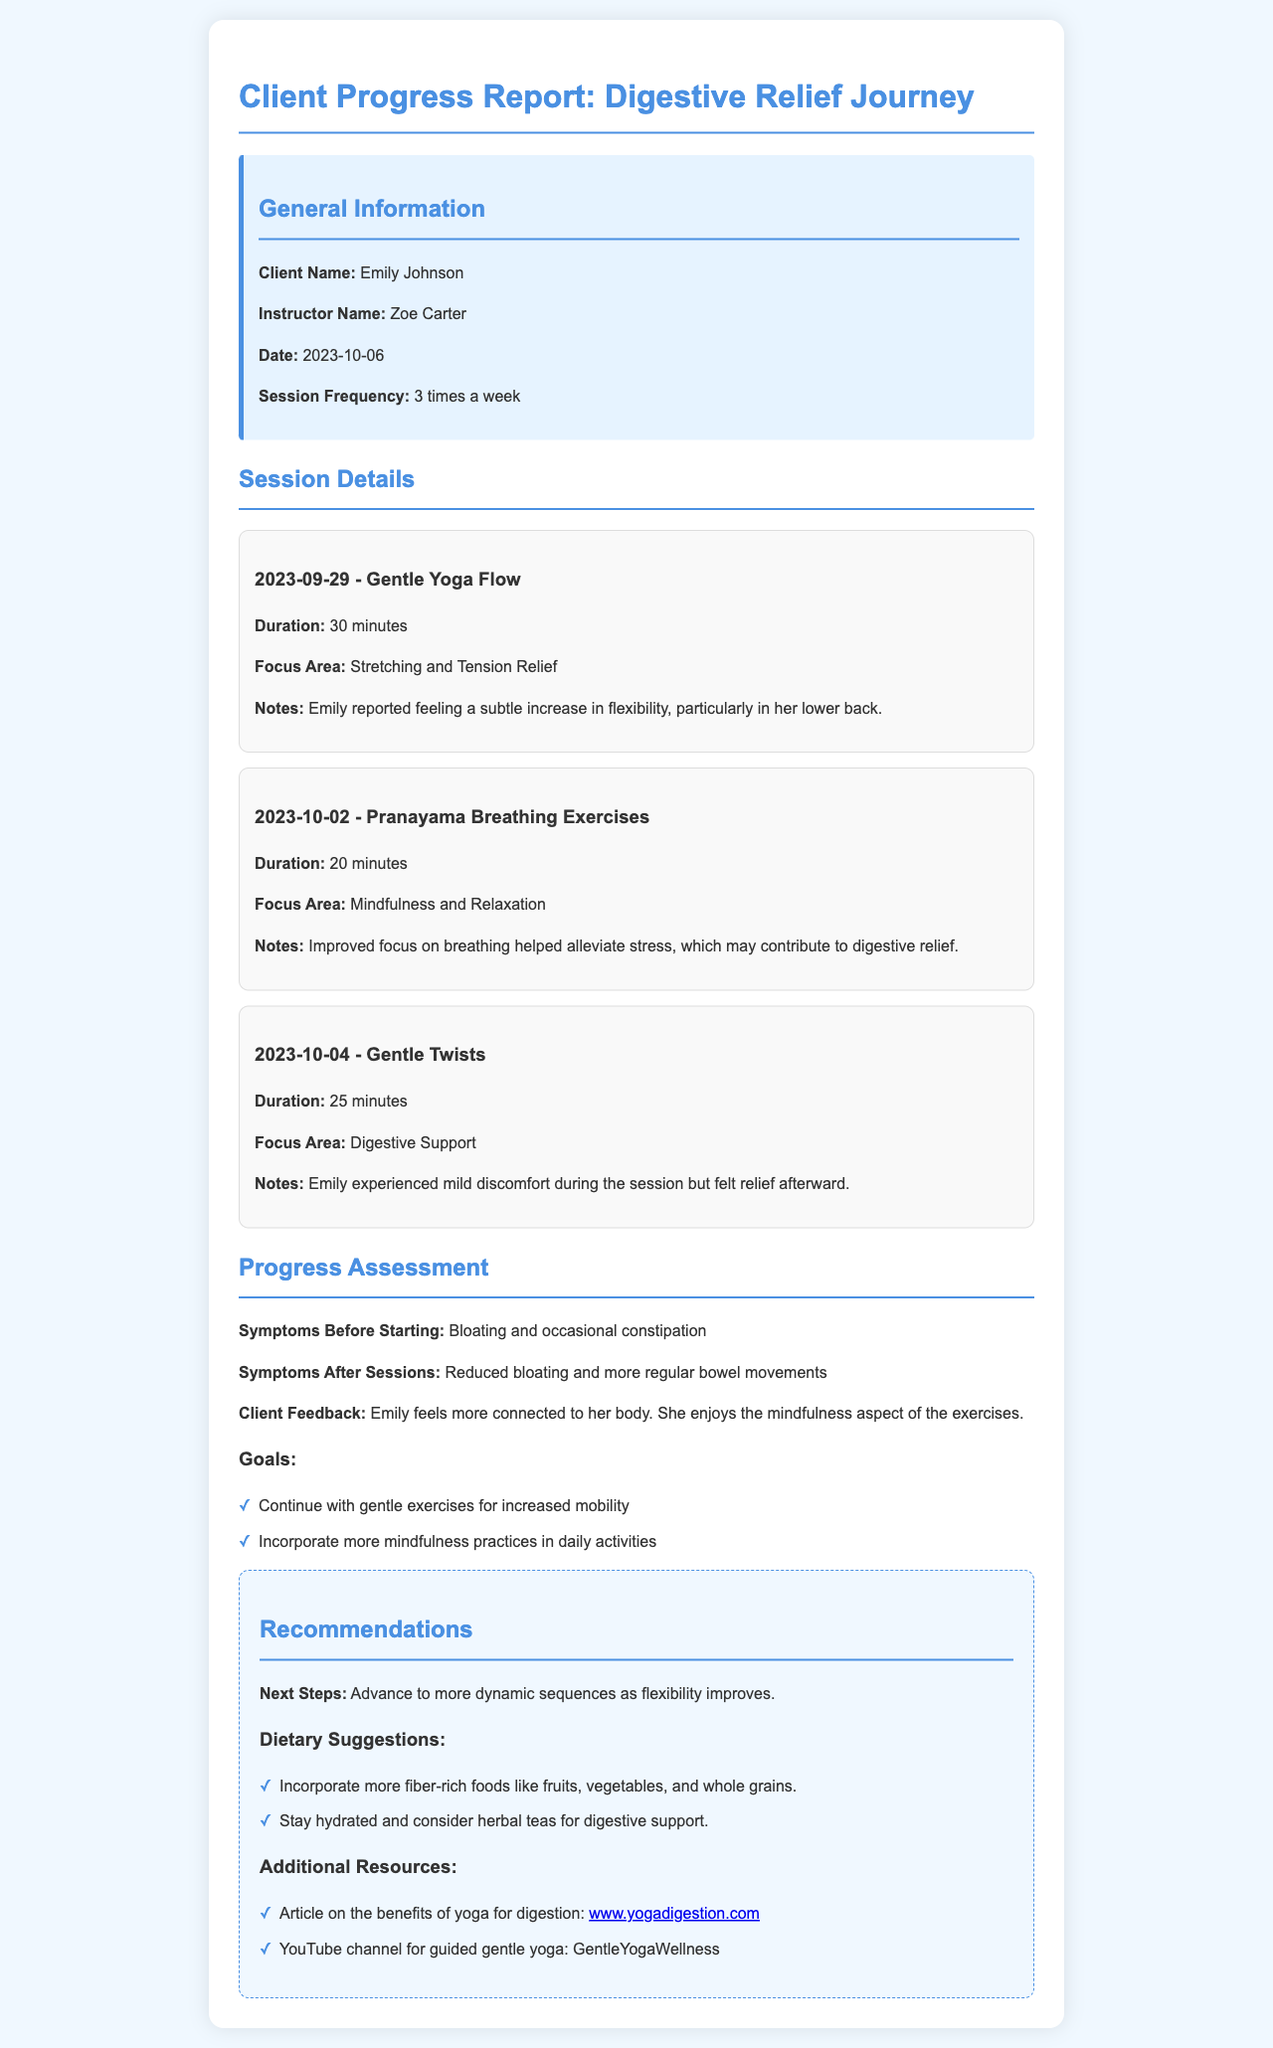what is the client name? The client name is provided in the General Information section of the document.
Answer: Emily Johnson who is the instructor name? The instructor name is listed right below the client name in the General Information section.
Answer: Zoe Carter when was the last session held? The date of the last session is indicated in the session details.
Answer: 2023-10-04 what was the focus area of the session on 2023-10-02? The focus area is detailed in the corresponding session card within the document.
Answer: Mindfulness and Relaxation how many times per week does the client attend sessions? This information is provided in the General Information section.
Answer: 3 times a week what was the client's feedback about the sessions? The client's feedback summarizes her feelings regarding her journey in the Progress Assessment section.
Answer: More connected to her body what are the client’s symptoms before starting sessions? The symptoms before starting are specifically listed in the Progress Assessment section.
Answer: Bloating and occasional constipation what is the next step recommended for the client? The next steps are outlined in the Recommendations section, providing guidance for progression.
Answer: Advance to more dynamic sequences as flexibility improves which dietary suggestions are made for the client? The dietary suggestions are mentioned in a specific section within the Recommendations.
Answer: More fiber-rich foods what additional resource is suggested for the client? This refers to the additional resources listed in the Recommendations section of the document.
Answer: Article on the benefits of yoga for digestion 